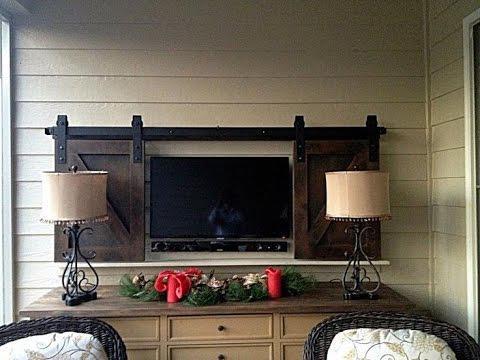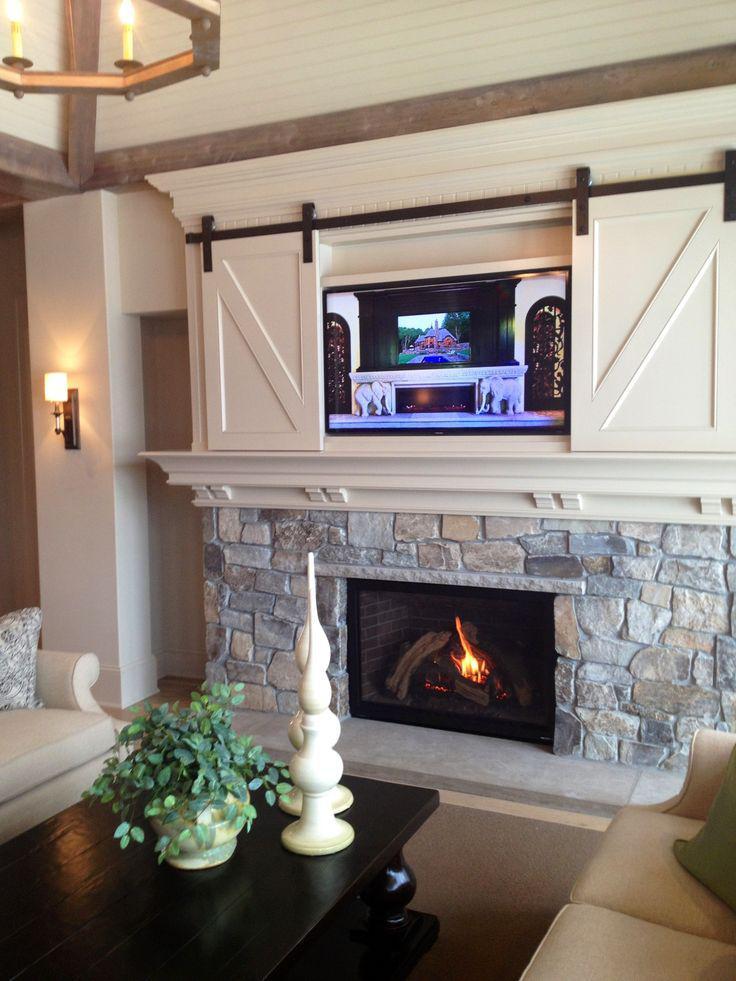The first image is the image on the left, the second image is the image on the right. Analyze the images presented: Is the assertion "An image shows 'barn doors' that slide on a black bar overhead, above a wide dresser with lamps on each end." valid? Answer yes or no. Yes. The first image is the image on the left, the second image is the image on the right. Assess this claim about the two images: "A sliding television cabinet is open.". Correct or not? Answer yes or no. Yes. 